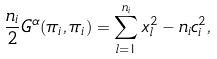Convert formula to latex. <formula><loc_0><loc_0><loc_500><loc_500>\frac { n _ { i } } { 2 } G ^ { \alpha } ( \pi _ { i } , \pi _ { i } ) = \sum ^ { n _ { i } } _ { l = 1 } x _ { l } ^ { 2 } - n _ { i } c _ { i } ^ { 2 } ,</formula> 